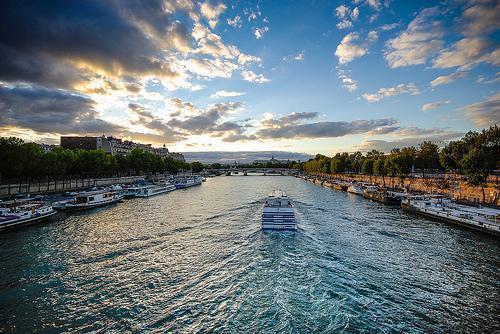How many boats are along the left side of the water?
Give a very brief answer. 4. 